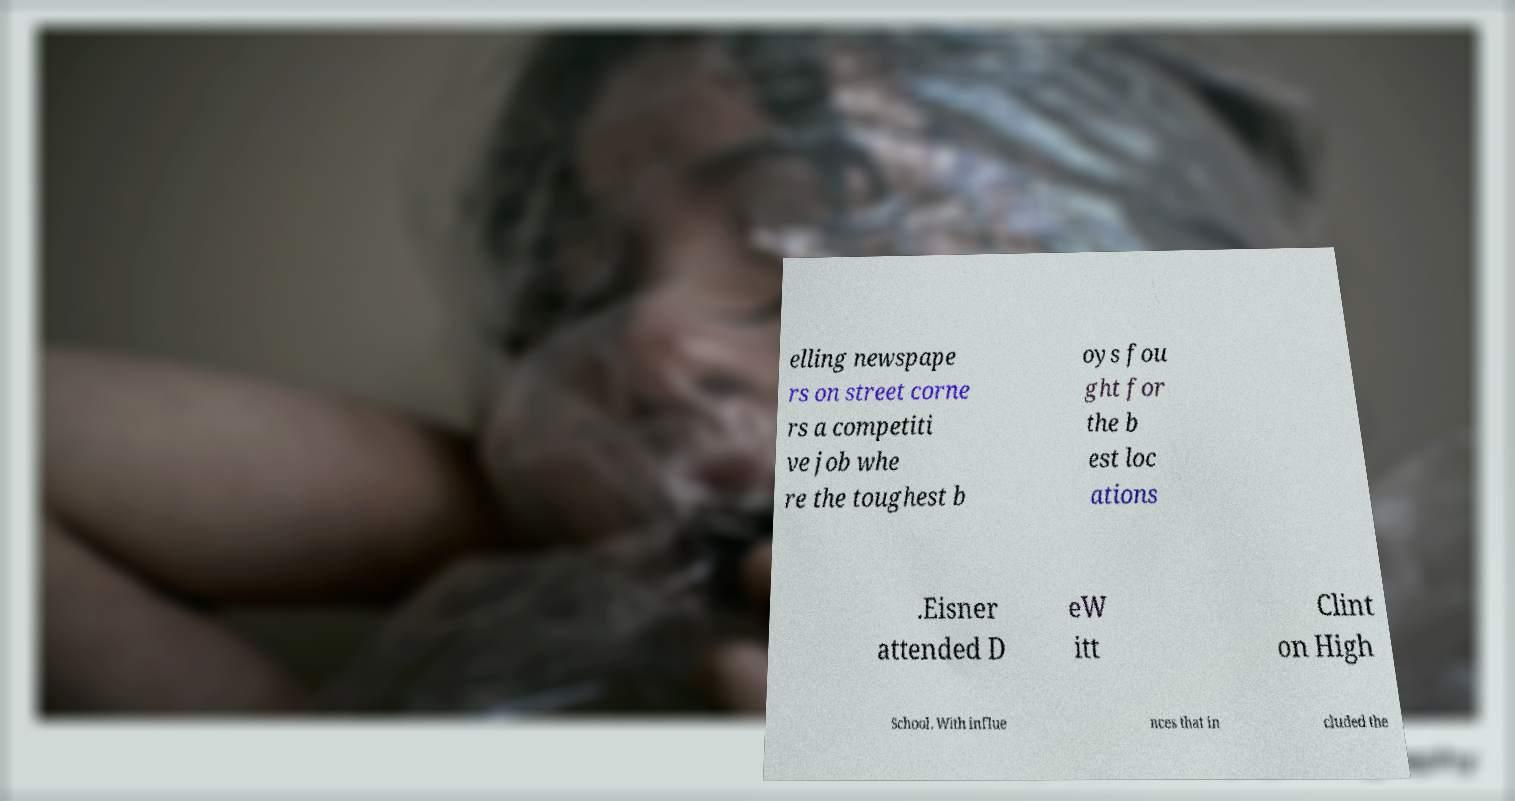There's text embedded in this image that I need extracted. Can you transcribe it verbatim? elling newspape rs on street corne rs a competiti ve job whe re the toughest b oys fou ght for the b est loc ations .Eisner attended D eW itt Clint on High School. With influe nces that in cluded the 